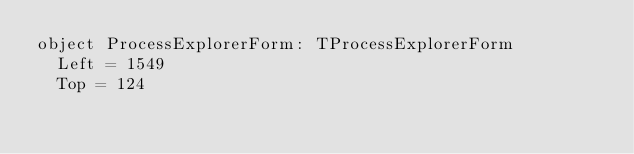Convert code to text. <code><loc_0><loc_0><loc_500><loc_500><_Pascal_>object ProcessExplorerForm: TProcessExplorerForm
  Left = 1549
  Top = 124</code> 